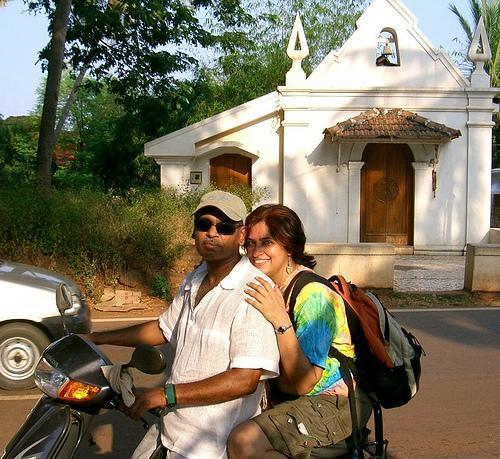How many people are shown?
Give a very brief answer. 2. How many people can you see?
Give a very brief answer. 2. How many cats are on the bench?
Give a very brief answer. 0. 